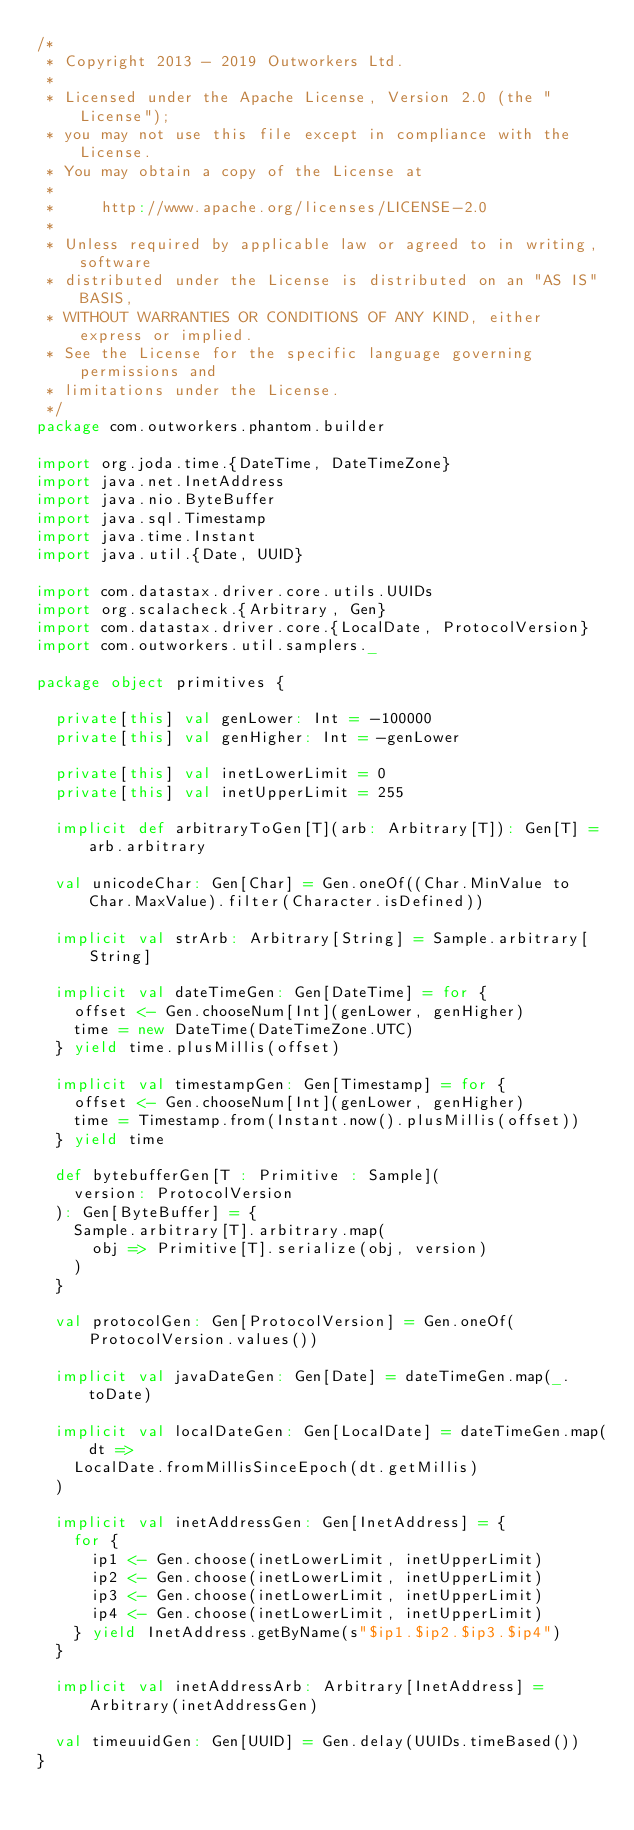<code> <loc_0><loc_0><loc_500><loc_500><_Scala_>/*
 * Copyright 2013 - 2019 Outworkers Ltd.
 *
 * Licensed under the Apache License, Version 2.0 (the "License");
 * you may not use this file except in compliance with the License.
 * You may obtain a copy of the License at
 *
 *     http://www.apache.org/licenses/LICENSE-2.0
 *
 * Unless required by applicable law or agreed to in writing, software
 * distributed under the License is distributed on an "AS IS" BASIS,
 * WITHOUT WARRANTIES OR CONDITIONS OF ANY KIND, either express or implied.
 * See the License for the specific language governing permissions and
 * limitations under the License.
 */
package com.outworkers.phantom.builder

import org.joda.time.{DateTime, DateTimeZone}
import java.net.InetAddress
import java.nio.ByteBuffer
import java.sql.Timestamp
import java.time.Instant
import java.util.{Date, UUID}

import com.datastax.driver.core.utils.UUIDs
import org.scalacheck.{Arbitrary, Gen}
import com.datastax.driver.core.{LocalDate, ProtocolVersion}
import com.outworkers.util.samplers._

package object primitives {

  private[this] val genLower: Int = -100000
  private[this] val genHigher: Int = -genLower

  private[this] val inetLowerLimit = 0
  private[this] val inetUpperLimit = 255

  implicit def arbitraryToGen[T](arb: Arbitrary[T]): Gen[T] = arb.arbitrary

  val unicodeChar: Gen[Char] = Gen.oneOf((Char.MinValue to Char.MaxValue).filter(Character.isDefined))

  implicit val strArb: Arbitrary[String] = Sample.arbitrary[String]

  implicit val dateTimeGen: Gen[DateTime] = for {
    offset <- Gen.chooseNum[Int](genLower, genHigher)
    time = new DateTime(DateTimeZone.UTC)
  } yield time.plusMillis(offset)

  implicit val timestampGen: Gen[Timestamp] = for {
    offset <- Gen.chooseNum[Int](genLower, genHigher)
    time = Timestamp.from(Instant.now().plusMillis(offset))
  } yield time

  def bytebufferGen[T : Primitive : Sample](
    version: ProtocolVersion
  ): Gen[ByteBuffer] = {
    Sample.arbitrary[T].arbitrary.map(
      obj => Primitive[T].serialize(obj, version)
    )
  }

  val protocolGen: Gen[ProtocolVersion] = Gen.oneOf(ProtocolVersion.values())

  implicit val javaDateGen: Gen[Date] = dateTimeGen.map(_.toDate)

  implicit val localDateGen: Gen[LocalDate] = dateTimeGen.map(dt =>
    LocalDate.fromMillisSinceEpoch(dt.getMillis)
  )

  implicit val inetAddressGen: Gen[InetAddress] = {
    for {
      ip1 <- Gen.choose(inetLowerLimit, inetUpperLimit)
      ip2 <- Gen.choose(inetLowerLimit, inetUpperLimit)
      ip3 <- Gen.choose(inetLowerLimit, inetUpperLimit)
      ip4 <- Gen.choose(inetLowerLimit, inetUpperLimit)
    } yield InetAddress.getByName(s"$ip1.$ip2.$ip3.$ip4")
  }

  implicit val inetAddressArb: Arbitrary[InetAddress] = Arbitrary(inetAddressGen)

  val timeuuidGen: Gen[UUID] = Gen.delay(UUIDs.timeBased())
}
</code> 